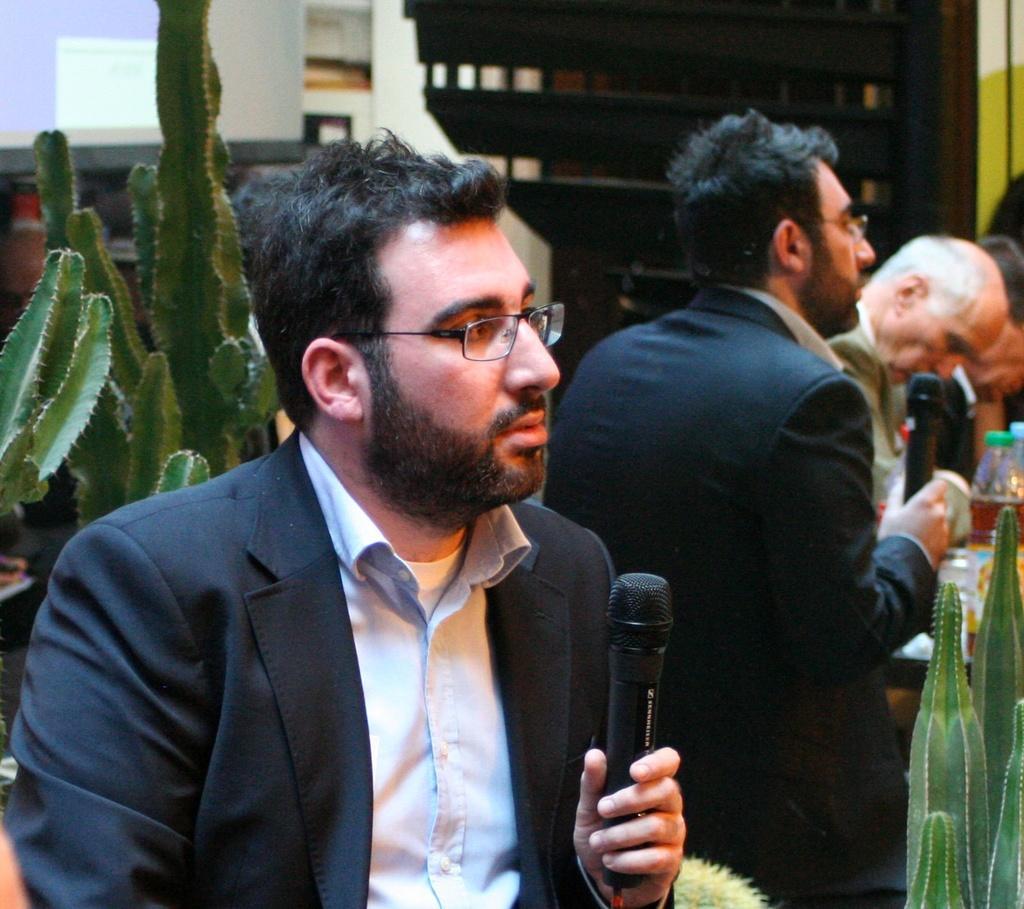Can you describe this image briefly? In this image i can see i can see a man holding a micro phone at the back ground see few other person's,a plant,a wooden cupboard. 